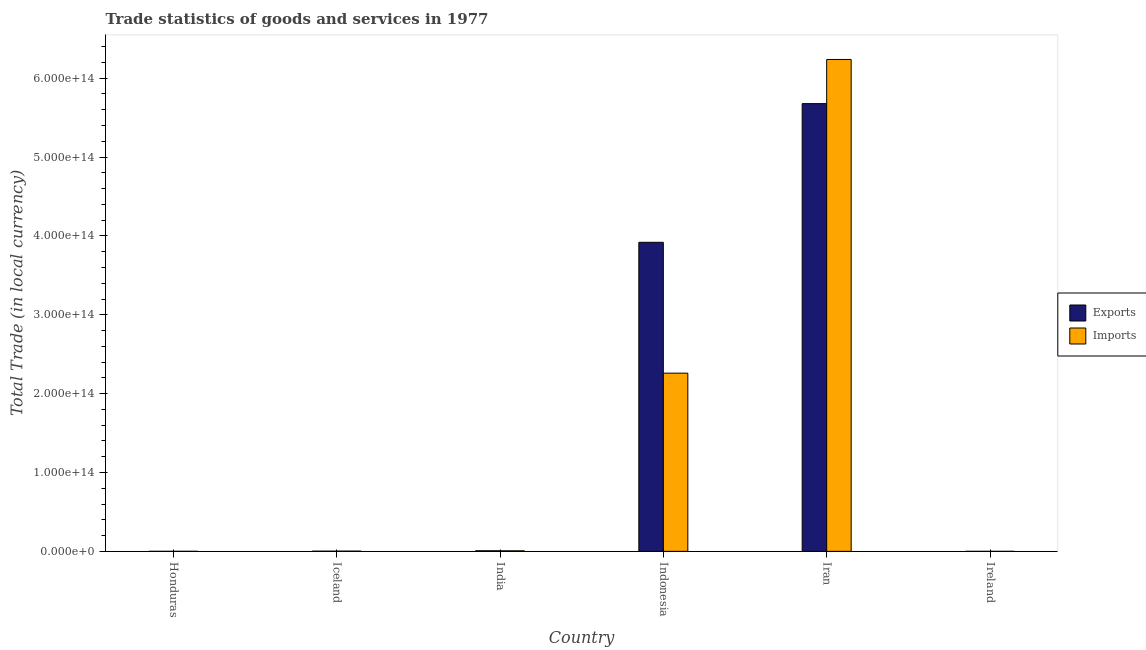How many groups of bars are there?
Offer a very short reply. 6. Are the number of bars on each tick of the X-axis equal?
Keep it short and to the point. Yes. How many bars are there on the 6th tick from the left?
Offer a terse response. 2. What is the label of the 3rd group of bars from the left?
Keep it short and to the point. India. What is the imports of goods and services in Honduras?
Ensure brevity in your answer.  4.32e+1. Across all countries, what is the maximum imports of goods and services?
Provide a short and direct response. 6.24e+14. Across all countries, what is the minimum export of goods and services?
Offer a very short reply. 8.85e+09. In which country was the export of goods and services maximum?
Your answer should be compact. Iran. In which country was the imports of goods and services minimum?
Your answer should be compact. Ireland. What is the total export of goods and services in the graph?
Your response must be concise. 9.61e+14. What is the difference between the export of goods and services in Honduras and that in Ireland?
Offer a terse response. 2.63e+1. What is the difference between the imports of goods and services in India and the export of goods and services in Ireland?
Your answer should be very brief. 6.73e+11. What is the average imports of goods and services per country?
Make the answer very short. 1.42e+14. What is the difference between the export of goods and services and imports of goods and services in India?
Your answer should be very brief. 6.38e+1. What is the ratio of the export of goods and services in Iran to that in Ireland?
Keep it short and to the point. 6.41e+04. Is the export of goods and services in Honduras less than that in India?
Ensure brevity in your answer.  Yes. Is the difference between the export of goods and services in Honduras and Ireland greater than the difference between the imports of goods and services in Honduras and Ireland?
Your answer should be compact. No. What is the difference between the highest and the second highest export of goods and services?
Make the answer very short. 1.76e+14. What is the difference between the highest and the lowest export of goods and services?
Keep it short and to the point. 5.68e+14. What does the 2nd bar from the left in Iceland represents?
Give a very brief answer. Imports. What does the 1st bar from the right in Iceland represents?
Ensure brevity in your answer.  Imports. How many bars are there?
Make the answer very short. 12. Are all the bars in the graph horizontal?
Your response must be concise. No. What is the difference between two consecutive major ticks on the Y-axis?
Ensure brevity in your answer.  1.00e+14. How many legend labels are there?
Make the answer very short. 2. How are the legend labels stacked?
Provide a succinct answer. Vertical. What is the title of the graph?
Provide a succinct answer. Trade statistics of goods and services in 1977. What is the label or title of the X-axis?
Keep it short and to the point. Country. What is the label or title of the Y-axis?
Ensure brevity in your answer.  Total Trade (in local currency). What is the Total Trade (in local currency) in Exports in Honduras?
Offer a terse response. 3.52e+1. What is the Total Trade (in local currency) in Imports in Honduras?
Offer a terse response. 4.32e+1. What is the Total Trade (in local currency) in Exports in Iceland?
Your answer should be compact. 2.37e+11. What is the Total Trade (in local currency) of Imports in Iceland?
Your response must be concise. 3.16e+11. What is the Total Trade (in local currency) in Exports in India?
Give a very brief answer. 7.46e+11. What is the Total Trade (in local currency) in Imports in India?
Keep it short and to the point. 6.82e+11. What is the Total Trade (in local currency) of Exports in Indonesia?
Your answer should be compact. 3.92e+14. What is the Total Trade (in local currency) of Imports in Indonesia?
Your answer should be very brief. 2.26e+14. What is the Total Trade (in local currency) of Exports in Iran?
Keep it short and to the point. 5.68e+14. What is the Total Trade (in local currency) in Imports in Iran?
Provide a short and direct response. 6.24e+14. What is the Total Trade (in local currency) in Exports in Ireland?
Your answer should be very brief. 8.85e+09. What is the Total Trade (in local currency) of Imports in Ireland?
Offer a very short reply. 1.26e+1. Across all countries, what is the maximum Total Trade (in local currency) in Exports?
Offer a terse response. 5.68e+14. Across all countries, what is the maximum Total Trade (in local currency) of Imports?
Keep it short and to the point. 6.24e+14. Across all countries, what is the minimum Total Trade (in local currency) in Exports?
Provide a short and direct response. 8.85e+09. Across all countries, what is the minimum Total Trade (in local currency) in Imports?
Make the answer very short. 1.26e+1. What is the total Total Trade (in local currency) in Exports in the graph?
Ensure brevity in your answer.  9.61e+14. What is the total Total Trade (in local currency) in Imports in the graph?
Provide a short and direct response. 8.51e+14. What is the difference between the Total Trade (in local currency) in Exports in Honduras and that in Iceland?
Ensure brevity in your answer.  -2.02e+11. What is the difference between the Total Trade (in local currency) in Imports in Honduras and that in Iceland?
Give a very brief answer. -2.72e+11. What is the difference between the Total Trade (in local currency) in Exports in Honduras and that in India?
Keep it short and to the point. -7.11e+11. What is the difference between the Total Trade (in local currency) in Imports in Honduras and that in India?
Offer a terse response. -6.39e+11. What is the difference between the Total Trade (in local currency) of Exports in Honduras and that in Indonesia?
Offer a terse response. -3.92e+14. What is the difference between the Total Trade (in local currency) in Imports in Honduras and that in Indonesia?
Your response must be concise. -2.26e+14. What is the difference between the Total Trade (in local currency) in Exports in Honduras and that in Iran?
Your response must be concise. -5.68e+14. What is the difference between the Total Trade (in local currency) of Imports in Honduras and that in Iran?
Your answer should be very brief. -6.24e+14. What is the difference between the Total Trade (in local currency) in Exports in Honduras and that in Ireland?
Give a very brief answer. 2.63e+1. What is the difference between the Total Trade (in local currency) of Imports in Honduras and that in Ireland?
Your answer should be very brief. 3.06e+1. What is the difference between the Total Trade (in local currency) of Exports in Iceland and that in India?
Offer a terse response. -5.09e+11. What is the difference between the Total Trade (in local currency) of Imports in Iceland and that in India?
Provide a succinct answer. -3.67e+11. What is the difference between the Total Trade (in local currency) in Exports in Iceland and that in Indonesia?
Your answer should be compact. -3.92e+14. What is the difference between the Total Trade (in local currency) of Imports in Iceland and that in Indonesia?
Give a very brief answer. -2.26e+14. What is the difference between the Total Trade (in local currency) in Exports in Iceland and that in Iran?
Your answer should be compact. -5.68e+14. What is the difference between the Total Trade (in local currency) of Imports in Iceland and that in Iran?
Offer a very short reply. -6.23e+14. What is the difference between the Total Trade (in local currency) in Exports in Iceland and that in Ireland?
Offer a terse response. 2.29e+11. What is the difference between the Total Trade (in local currency) in Imports in Iceland and that in Ireland?
Provide a short and direct response. 3.03e+11. What is the difference between the Total Trade (in local currency) in Exports in India and that in Indonesia?
Ensure brevity in your answer.  -3.91e+14. What is the difference between the Total Trade (in local currency) in Imports in India and that in Indonesia?
Give a very brief answer. -2.25e+14. What is the difference between the Total Trade (in local currency) in Exports in India and that in Iran?
Give a very brief answer. -5.67e+14. What is the difference between the Total Trade (in local currency) of Imports in India and that in Iran?
Offer a very short reply. -6.23e+14. What is the difference between the Total Trade (in local currency) of Exports in India and that in Ireland?
Provide a succinct answer. 7.37e+11. What is the difference between the Total Trade (in local currency) of Imports in India and that in Ireland?
Provide a succinct answer. 6.70e+11. What is the difference between the Total Trade (in local currency) of Exports in Indonesia and that in Iran?
Your response must be concise. -1.76e+14. What is the difference between the Total Trade (in local currency) of Imports in Indonesia and that in Iran?
Provide a succinct answer. -3.98e+14. What is the difference between the Total Trade (in local currency) in Exports in Indonesia and that in Ireland?
Provide a short and direct response. 3.92e+14. What is the difference between the Total Trade (in local currency) in Imports in Indonesia and that in Ireland?
Offer a terse response. 2.26e+14. What is the difference between the Total Trade (in local currency) in Exports in Iran and that in Ireland?
Your answer should be compact. 5.68e+14. What is the difference between the Total Trade (in local currency) of Imports in Iran and that in Ireland?
Provide a succinct answer. 6.24e+14. What is the difference between the Total Trade (in local currency) in Exports in Honduras and the Total Trade (in local currency) in Imports in Iceland?
Keep it short and to the point. -2.80e+11. What is the difference between the Total Trade (in local currency) in Exports in Honduras and the Total Trade (in local currency) in Imports in India?
Ensure brevity in your answer.  -6.47e+11. What is the difference between the Total Trade (in local currency) of Exports in Honduras and the Total Trade (in local currency) of Imports in Indonesia?
Provide a short and direct response. -2.26e+14. What is the difference between the Total Trade (in local currency) of Exports in Honduras and the Total Trade (in local currency) of Imports in Iran?
Provide a short and direct response. -6.24e+14. What is the difference between the Total Trade (in local currency) of Exports in Honduras and the Total Trade (in local currency) of Imports in Ireland?
Offer a very short reply. 2.26e+1. What is the difference between the Total Trade (in local currency) of Exports in Iceland and the Total Trade (in local currency) of Imports in India?
Your answer should be very brief. -4.45e+11. What is the difference between the Total Trade (in local currency) of Exports in Iceland and the Total Trade (in local currency) of Imports in Indonesia?
Keep it short and to the point. -2.26e+14. What is the difference between the Total Trade (in local currency) of Exports in Iceland and the Total Trade (in local currency) of Imports in Iran?
Offer a terse response. -6.24e+14. What is the difference between the Total Trade (in local currency) of Exports in Iceland and the Total Trade (in local currency) of Imports in Ireland?
Your response must be concise. 2.25e+11. What is the difference between the Total Trade (in local currency) of Exports in India and the Total Trade (in local currency) of Imports in Indonesia?
Give a very brief answer. -2.25e+14. What is the difference between the Total Trade (in local currency) of Exports in India and the Total Trade (in local currency) of Imports in Iran?
Provide a short and direct response. -6.23e+14. What is the difference between the Total Trade (in local currency) in Exports in India and the Total Trade (in local currency) in Imports in Ireland?
Your answer should be compact. 7.34e+11. What is the difference between the Total Trade (in local currency) of Exports in Indonesia and the Total Trade (in local currency) of Imports in Iran?
Provide a short and direct response. -2.32e+14. What is the difference between the Total Trade (in local currency) in Exports in Indonesia and the Total Trade (in local currency) in Imports in Ireland?
Provide a succinct answer. 3.92e+14. What is the difference between the Total Trade (in local currency) of Exports in Iran and the Total Trade (in local currency) of Imports in Ireland?
Make the answer very short. 5.68e+14. What is the average Total Trade (in local currency) in Exports per country?
Keep it short and to the point. 1.60e+14. What is the average Total Trade (in local currency) of Imports per country?
Give a very brief answer. 1.42e+14. What is the difference between the Total Trade (in local currency) in Exports and Total Trade (in local currency) in Imports in Honduras?
Make the answer very short. -8.07e+09. What is the difference between the Total Trade (in local currency) of Exports and Total Trade (in local currency) of Imports in Iceland?
Your response must be concise. -7.83e+1. What is the difference between the Total Trade (in local currency) of Exports and Total Trade (in local currency) of Imports in India?
Offer a very short reply. 6.38e+1. What is the difference between the Total Trade (in local currency) of Exports and Total Trade (in local currency) of Imports in Indonesia?
Provide a succinct answer. 1.66e+14. What is the difference between the Total Trade (in local currency) of Exports and Total Trade (in local currency) of Imports in Iran?
Ensure brevity in your answer.  -5.60e+13. What is the difference between the Total Trade (in local currency) of Exports and Total Trade (in local currency) of Imports in Ireland?
Provide a short and direct response. -3.75e+09. What is the ratio of the Total Trade (in local currency) of Exports in Honduras to that in Iceland?
Your response must be concise. 0.15. What is the ratio of the Total Trade (in local currency) in Imports in Honduras to that in Iceland?
Provide a succinct answer. 0.14. What is the ratio of the Total Trade (in local currency) of Exports in Honduras to that in India?
Make the answer very short. 0.05. What is the ratio of the Total Trade (in local currency) in Imports in Honduras to that in India?
Offer a terse response. 0.06. What is the ratio of the Total Trade (in local currency) of Exports in Honduras to that in Indonesia?
Give a very brief answer. 0. What is the ratio of the Total Trade (in local currency) in Imports in Honduras to that in Indonesia?
Keep it short and to the point. 0. What is the ratio of the Total Trade (in local currency) in Exports in Honduras to that in Iran?
Offer a terse response. 0. What is the ratio of the Total Trade (in local currency) in Exports in Honduras to that in Ireland?
Your answer should be very brief. 3.97. What is the ratio of the Total Trade (in local currency) in Imports in Honduras to that in Ireland?
Provide a short and direct response. 3.43. What is the ratio of the Total Trade (in local currency) of Exports in Iceland to that in India?
Your answer should be very brief. 0.32. What is the ratio of the Total Trade (in local currency) in Imports in Iceland to that in India?
Make the answer very short. 0.46. What is the ratio of the Total Trade (in local currency) in Exports in Iceland to that in Indonesia?
Ensure brevity in your answer.  0. What is the ratio of the Total Trade (in local currency) of Imports in Iceland to that in Indonesia?
Ensure brevity in your answer.  0. What is the ratio of the Total Trade (in local currency) of Imports in Iceland to that in Iran?
Your answer should be very brief. 0. What is the ratio of the Total Trade (in local currency) of Exports in Iceland to that in Ireland?
Offer a terse response. 26.82. What is the ratio of the Total Trade (in local currency) in Imports in Iceland to that in Ireland?
Your response must be concise. 25.05. What is the ratio of the Total Trade (in local currency) in Exports in India to that in Indonesia?
Keep it short and to the point. 0. What is the ratio of the Total Trade (in local currency) in Imports in India to that in Indonesia?
Keep it short and to the point. 0. What is the ratio of the Total Trade (in local currency) of Exports in India to that in Iran?
Make the answer very short. 0. What is the ratio of the Total Trade (in local currency) of Imports in India to that in Iran?
Provide a succinct answer. 0. What is the ratio of the Total Trade (in local currency) of Exports in India to that in Ireland?
Your answer should be very brief. 84.29. What is the ratio of the Total Trade (in local currency) of Imports in India to that in Ireland?
Offer a very short reply. 54.16. What is the ratio of the Total Trade (in local currency) of Exports in Indonesia to that in Iran?
Your answer should be compact. 0.69. What is the ratio of the Total Trade (in local currency) of Imports in Indonesia to that in Iran?
Keep it short and to the point. 0.36. What is the ratio of the Total Trade (in local currency) in Exports in Indonesia to that in Ireland?
Offer a very short reply. 4.43e+04. What is the ratio of the Total Trade (in local currency) of Imports in Indonesia to that in Ireland?
Provide a short and direct response. 1.79e+04. What is the ratio of the Total Trade (in local currency) of Exports in Iran to that in Ireland?
Make the answer very short. 6.41e+04. What is the ratio of the Total Trade (in local currency) in Imports in Iran to that in Ireland?
Make the answer very short. 4.95e+04. What is the difference between the highest and the second highest Total Trade (in local currency) of Exports?
Your response must be concise. 1.76e+14. What is the difference between the highest and the second highest Total Trade (in local currency) in Imports?
Provide a short and direct response. 3.98e+14. What is the difference between the highest and the lowest Total Trade (in local currency) in Exports?
Provide a short and direct response. 5.68e+14. What is the difference between the highest and the lowest Total Trade (in local currency) of Imports?
Your answer should be compact. 6.24e+14. 